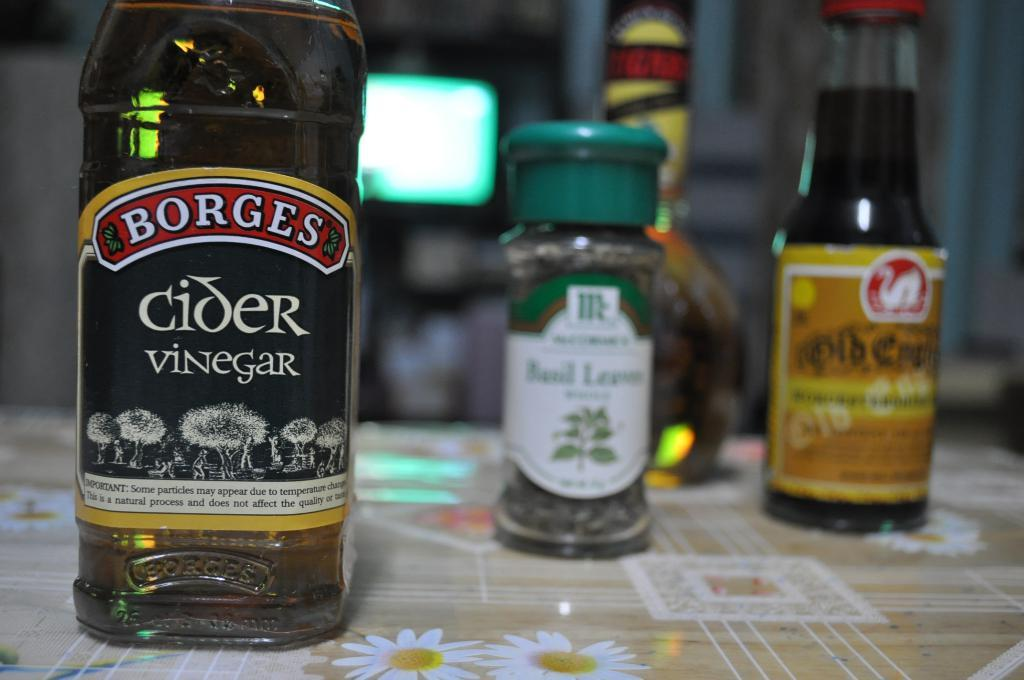<image>
Render a clear and concise summary of the photo. A bottle of Borges Cider Vinegar is in front of two other bottles. 